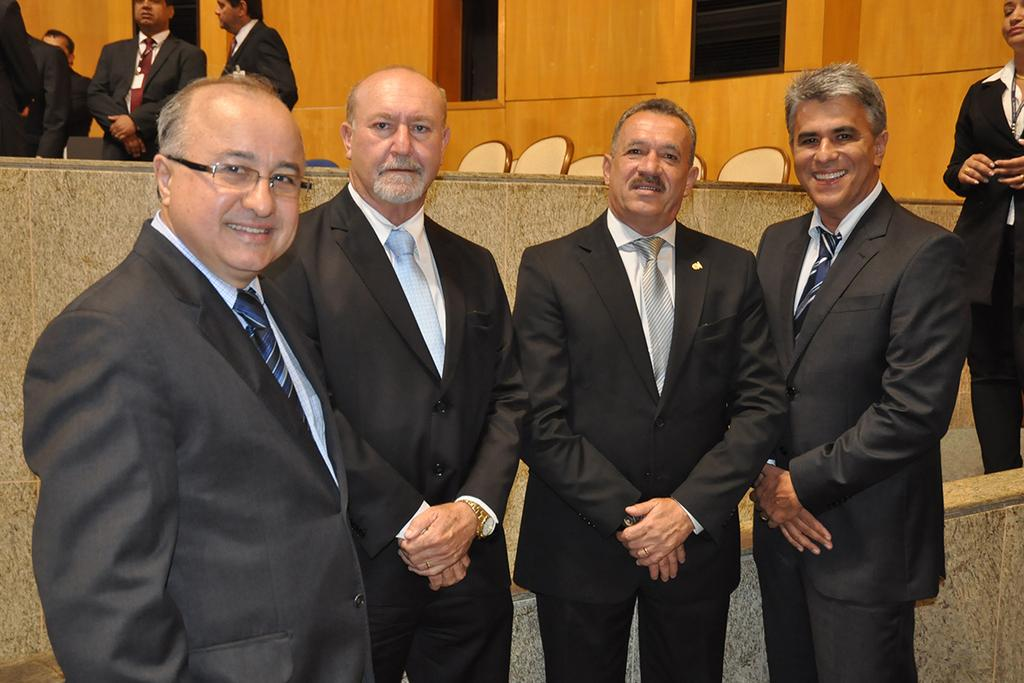What is the main subject of the image? The main subject of the image is a group of people. What can be observed about the attire of some men in the group? Some men in the group are wearing colorful suits. What can be seen in the background of the image? There are chairs and a wall in the background of the image. Can you see a goose sitting on the swing in the image? There is no swing or goose present in the image. 